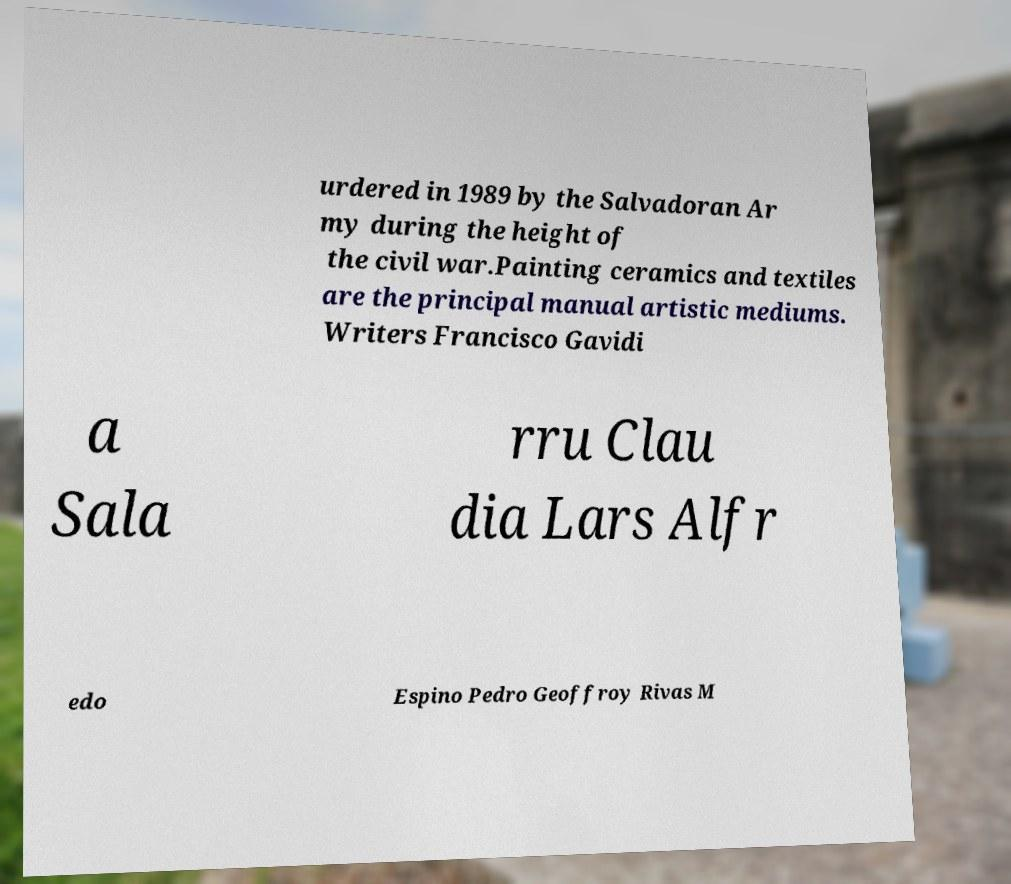There's text embedded in this image that I need extracted. Can you transcribe it verbatim? urdered in 1989 by the Salvadoran Ar my during the height of the civil war.Painting ceramics and textiles are the principal manual artistic mediums. Writers Francisco Gavidi a Sala rru Clau dia Lars Alfr edo Espino Pedro Geoffroy Rivas M 